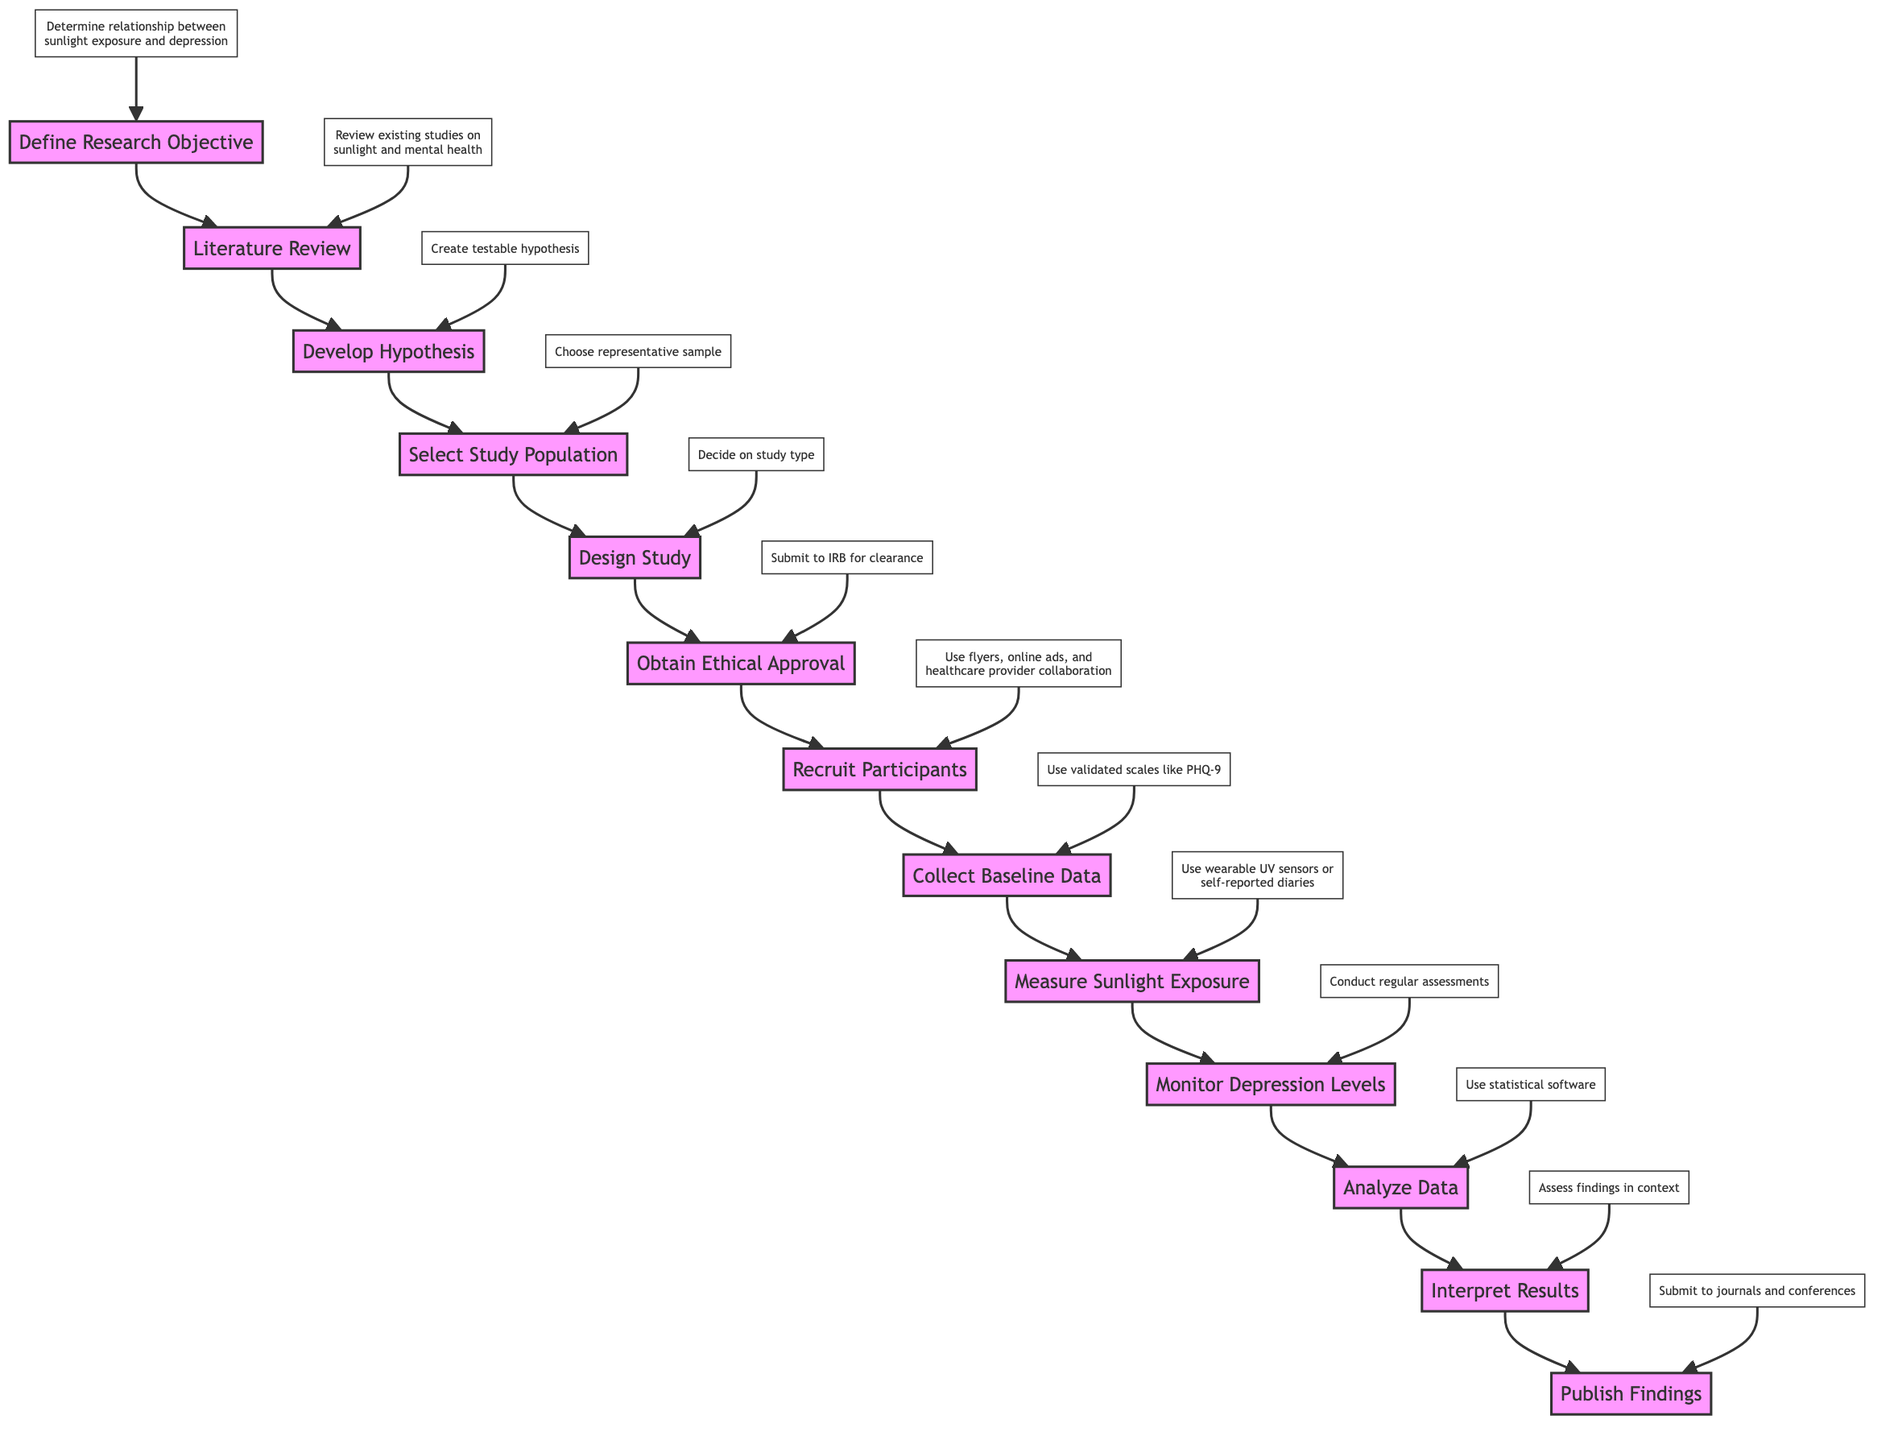What is the first step in the study? According to the flowchart, the first step indicated is "Define Research Objective," which is connected to the starting point of the diagram.
Answer: Define Research Objective How many nodes are in the diagram? By counting each distinct step or action presented in the flowchart, we find there are a total of 13 nodes representing different steps in the study process.
Answer: 13 What is the last step in the process? The final node in the flowchart is "Publish Findings," shown at the end of the instruction sequence.
Answer: Publish Findings What follows after "Recruit Participants"? The node directly following "Recruit Participants" is "Collect Baseline Data," indicating the next step to be taken.
Answer: Collect Baseline Data What is the purpose of the "Literature Review" step? The purpose indicated in the flowchart for "Literature Review" is to "Review existing studies on sunlight and mental health," which provides context for the current research.
Answer: Review existing studies on sunlight and mental health Which step requires ethical clearance? The flowchart specifies that "Obtain Ethical Approval" is the step that requires submitting the study proposal to an Institutional Review Board for ethical clearance.
Answer: Obtain Ethical Approval What type of study design options are available? The "Design Study" step indicates that one must decide on either a "longitudinal observational study or randomized controlled trial," presenting options for the research design.
Answer: Longitudinal observational study or randomized controlled trial How is "Sunlight Exposure" measured according to the diagram? The flowchart outlines that "Measure Sunlight Exposure" can be achieved using "wearable UV sensors or self-reported diaries," which are two different methods for tracking exposure.
Answer: Wearable UV sensors or self-reported diaries In which step do participants’ depression levels get monitored? The node "Monitor Depression Levels" specifically addresses the regular assessment of participants' depression, indicating it as the step where monitoring occurs.
Answer: Monitor Depression Levels 